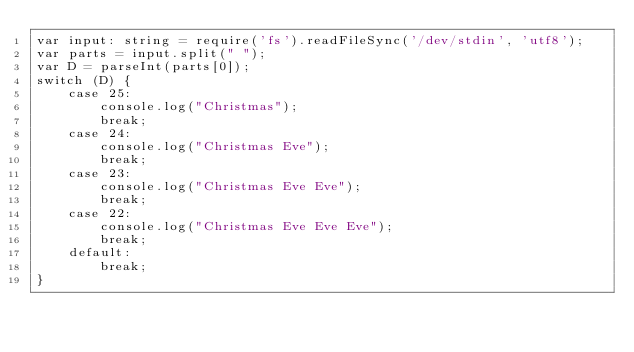<code> <loc_0><loc_0><loc_500><loc_500><_TypeScript_>var input: string = require('fs').readFileSync('/dev/stdin', 'utf8');
var parts = input.split(" ");
var D = parseInt(parts[0]);
switch (D) {
    case 25:
        console.log("Christmas");
        break;
    case 24:
        console.log("Christmas Eve");
        break;
    case 23:
        console.log("Christmas Eve Eve");
        break;
    case 22:
        console.log("Christmas Eve Eve Eve");
        break;
    default:
        break;
}</code> 